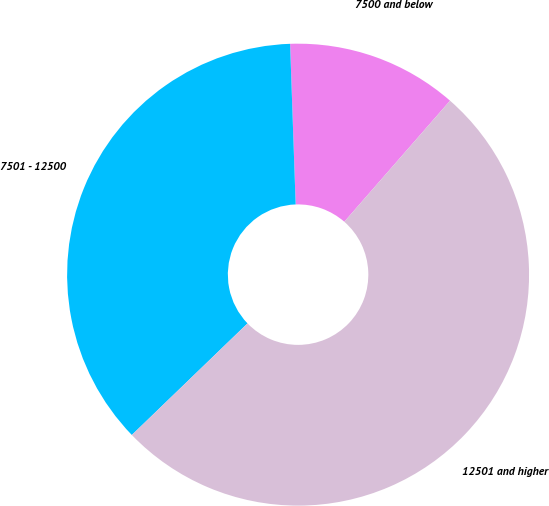Convert chart. <chart><loc_0><loc_0><loc_500><loc_500><pie_chart><fcel>7500 and below<fcel>7501 - 12500<fcel>12501 and higher<nl><fcel>11.98%<fcel>36.66%<fcel>51.36%<nl></chart> 